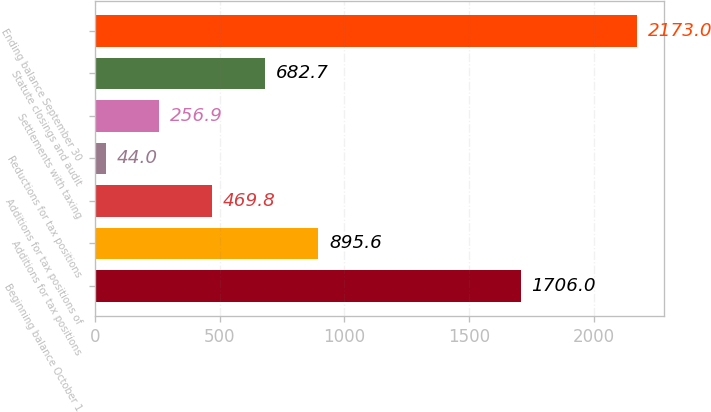Convert chart. <chart><loc_0><loc_0><loc_500><loc_500><bar_chart><fcel>Beginning balance October 1<fcel>Additions for tax positions<fcel>Additions for tax positions of<fcel>Reductions for tax positions<fcel>Settlements with taxing<fcel>Statute closings and audit<fcel>Ending balance September 30<nl><fcel>1706<fcel>895.6<fcel>469.8<fcel>44<fcel>256.9<fcel>682.7<fcel>2173<nl></chart> 